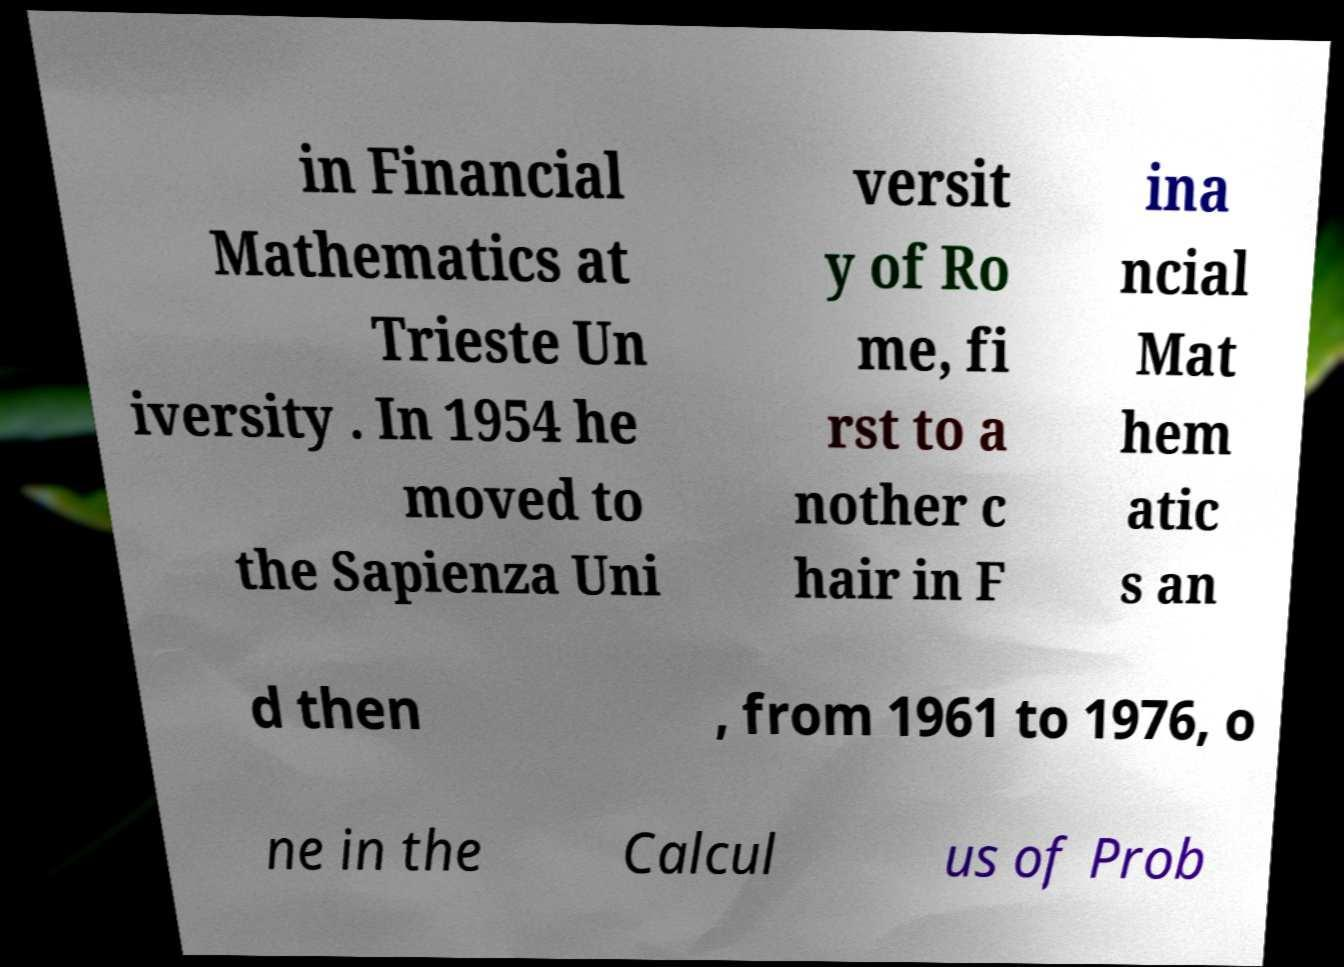I need the written content from this picture converted into text. Can you do that? in Financial Mathematics at Trieste Un iversity . In 1954 he moved to the Sapienza Uni versit y of Ro me, fi rst to a nother c hair in F ina ncial Mat hem atic s an d then , from 1961 to 1976, o ne in the Calcul us of Prob 